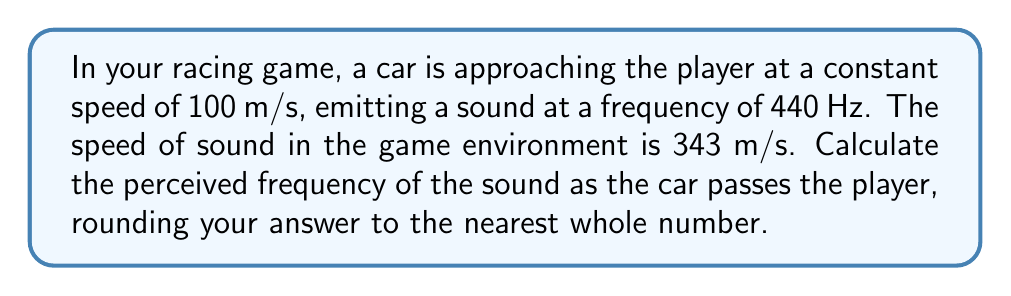Could you help me with this problem? To solve this problem, we'll use the Doppler effect formula:

$$f' = f \cdot \frac{c}{c - v_s}$$

Where:
$f'$ = perceived frequency
$f$ = source frequency
$c$ = speed of sound
$v_s$ = speed of the source relative to the observer (positive when approaching)

Step 1: Identify the given values
$f = 440$ Hz
$c = 343$ m/s
$v_s = 100$ m/s

Step 2: Plug the values into the formula
$$f' = 440 \cdot \frac{343}{343 - 100}$$

Step 3: Simplify the fraction
$$f' = 440 \cdot \frac{343}{243}$$

Step 4: Calculate the result
$$f' \approx 620.99$$

Step 5: Round to the nearest whole number
$$f' \approx 621 \text{ Hz}$$

This increase in frequency will create the characteristic rise in pitch as the car approaches the player in your racing game.
Answer: 621 Hz 